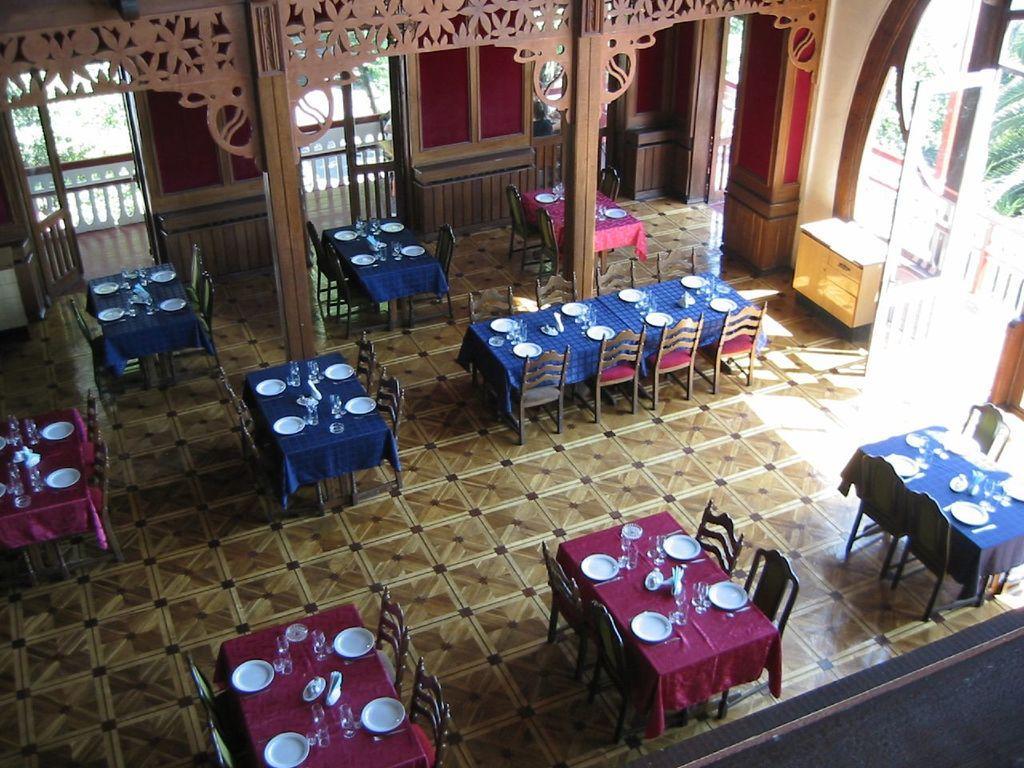Describe this image in one or two sentences. In this image we can see the top view of a room. In the room we can see cement grills, floor, chairs, tables, crockery, cutlery, cupboards and walls. 